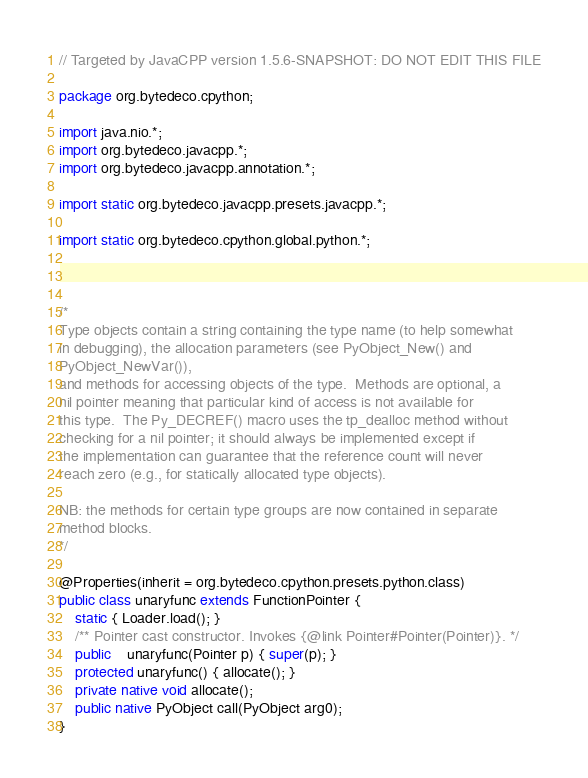Convert code to text. <code><loc_0><loc_0><loc_500><loc_500><_Java_>// Targeted by JavaCPP version 1.5.6-SNAPSHOT: DO NOT EDIT THIS FILE

package org.bytedeco.cpython;

import java.nio.*;
import org.bytedeco.javacpp.*;
import org.bytedeco.javacpp.annotation.*;

import static org.bytedeco.javacpp.presets.javacpp.*;

import static org.bytedeco.cpython.global.python.*;



/*
Type objects contain a string containing the type name (to help somewhat
in debugging), the allocation parameters (see PyObject_New() and
PyObject_NewVar()),
and methods for accessing objects of the type.  Methods are optional, a
nil pointer meaning that particular kind of access is not available for
this type.  The Py_DECREF() macro uses the tp_dealloc method without
checking for a nil pointer; it should always be implemented except if
the implementation can guarantee that the reference count will never
reach zero (e.g., for statically allocated type objects).

NB: the methods for certain type groups are now contained in separate
method blocks.
*/

@Properties(inherit = org.bytedeco.cpython.presets.python.class)
public class unaryfunc extends FunctionPointer {
    static { Loader.load(); }
    /** Pointer cast constructor. Invokes {@link Pointer#Pointer(Pointer)}. */
    public    unaryfunc(Pointer p) { super(p); }
    protected unaryfunc() { allocate(); }
    private native void allocate();
    public native PyObject call(PyObject arg0);
}
</code> 